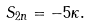Convert formula to latex. <formula><loc_0><loc_0><loc_500><loc_500>S _ { 2 n } = - 5 \kappa .</formula> 